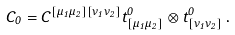Convert formula to latex. <formula><loc_0><loc_0><loc_500><loc_500>C _ { 0 } = C ^ { [ \mu _ { 1 } \mu _ { 2 } ] [ \nu _ { 1 } \nu _ { 2 } ] } t _ { [ \mu _ { 1 } \mu _ { 2 } ] } ^ { 0 } \otimes t _ { [ \nu _ { 1 } \nu _ { 2 } ] } ^ { 0 } \, .</formula> 